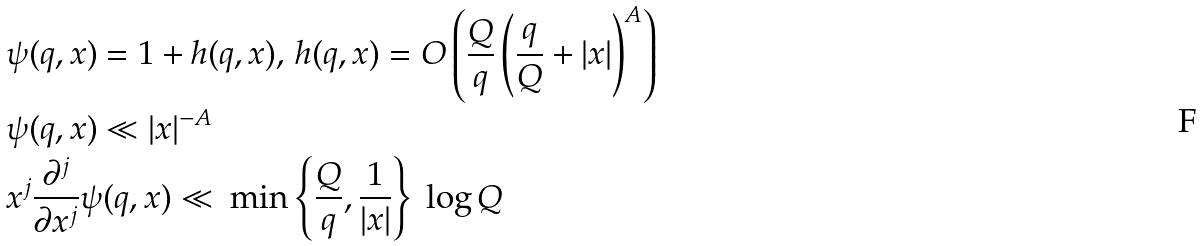Convert formula to latex. <formula><loc_0><loc_0><loc_500><loc_500>& \psi ( q , x ) = 1 + h ( q , x ) , \, h ( q , x ) = O \left ( \frac { Q } { q } \left ( \frac { q } { Q } + | x | \right ) ^ { A } \right ) \\ & \psi ( q , x ) \ll | x | ^ { - A } \\ & x ^ { j } \frac { \partial ^ { j } } { \partial x ^ { j } } \psi ( q , x ) \ll \ \min \left \{ \frac { Q } { q } , \frac { 1 } { | x | } \right \} \ \log Q</formula> 